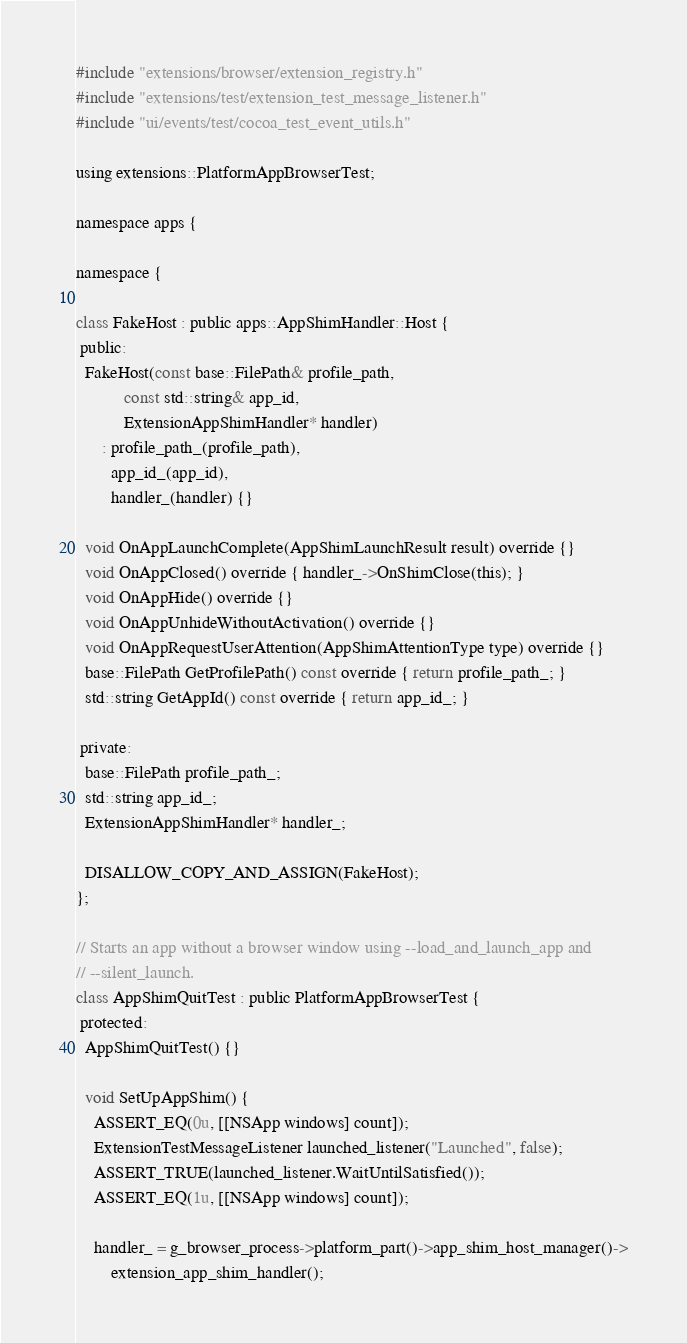<code> <loc_0><loc_0><loc_500><loc_500><_ObjectiveC_>#include "extensions/browser/extension_registry.h"
#include "extensions/test/extension_test_message_listener.h"
#include "ui/events/test/cocoa_test_event_utils.h"

using extensions::PlatformAppBrowserTest;

namespace apps {

namespace {

class FakeHost : public apps::AppShimHandler::Host {
 public:
  FakeHost(const base::FilePath& profile_path,
           const std::string& app_id,
           ExtensionAppShimHandler* handler)
      : profile_path_(profile_path),
        app_id_(app_id),
        handler_(handler) {}

  void OnAppLaunchComplete(AppShimLaunchResult result) override {}
  void OnAppClosed() override { handler_->OnShimClose(this); }
  void OnAppHide() override {}
  void OnAppUnhideWithoutActivation() override {}
  void OnAppRequestUserAttention(AppShimAttentionType type) override {}
  base::FilePath GetProfilePath() const override { return profile_path_; }
  std::string GetAppId() const override { return app_id_; }

 private:
  base::FilePath profile_path_;
  std::string app_id_;
  ExtensionAppShimHandler* handler_;

  DISALLOW_COPY_AND_ASSIGN(FakeHost);
};

// Starts an app without a browser window using --load_and_launch_app and
// --silent_launch.
class AppShimQuitTest : public PlatformAppBrowserTest {
 protected:
  AppShimQuitTest() {}

  void SetUpAppShim() {
    ASSERT_EQ(0u, [[NSApp windows] count]);
    ExtensionTestMessageListener launched_listener("Launched", false);
    ASSERT_TRUE(launched_listener.WaitUntilSatisfied());
    ASSERT_EQ(1u, [[NSApp windows] count]);

    handler_ = g_browser_process->platform_part()->app_shim_host_manager()->
        extension_app_shim_handler();
</code> 